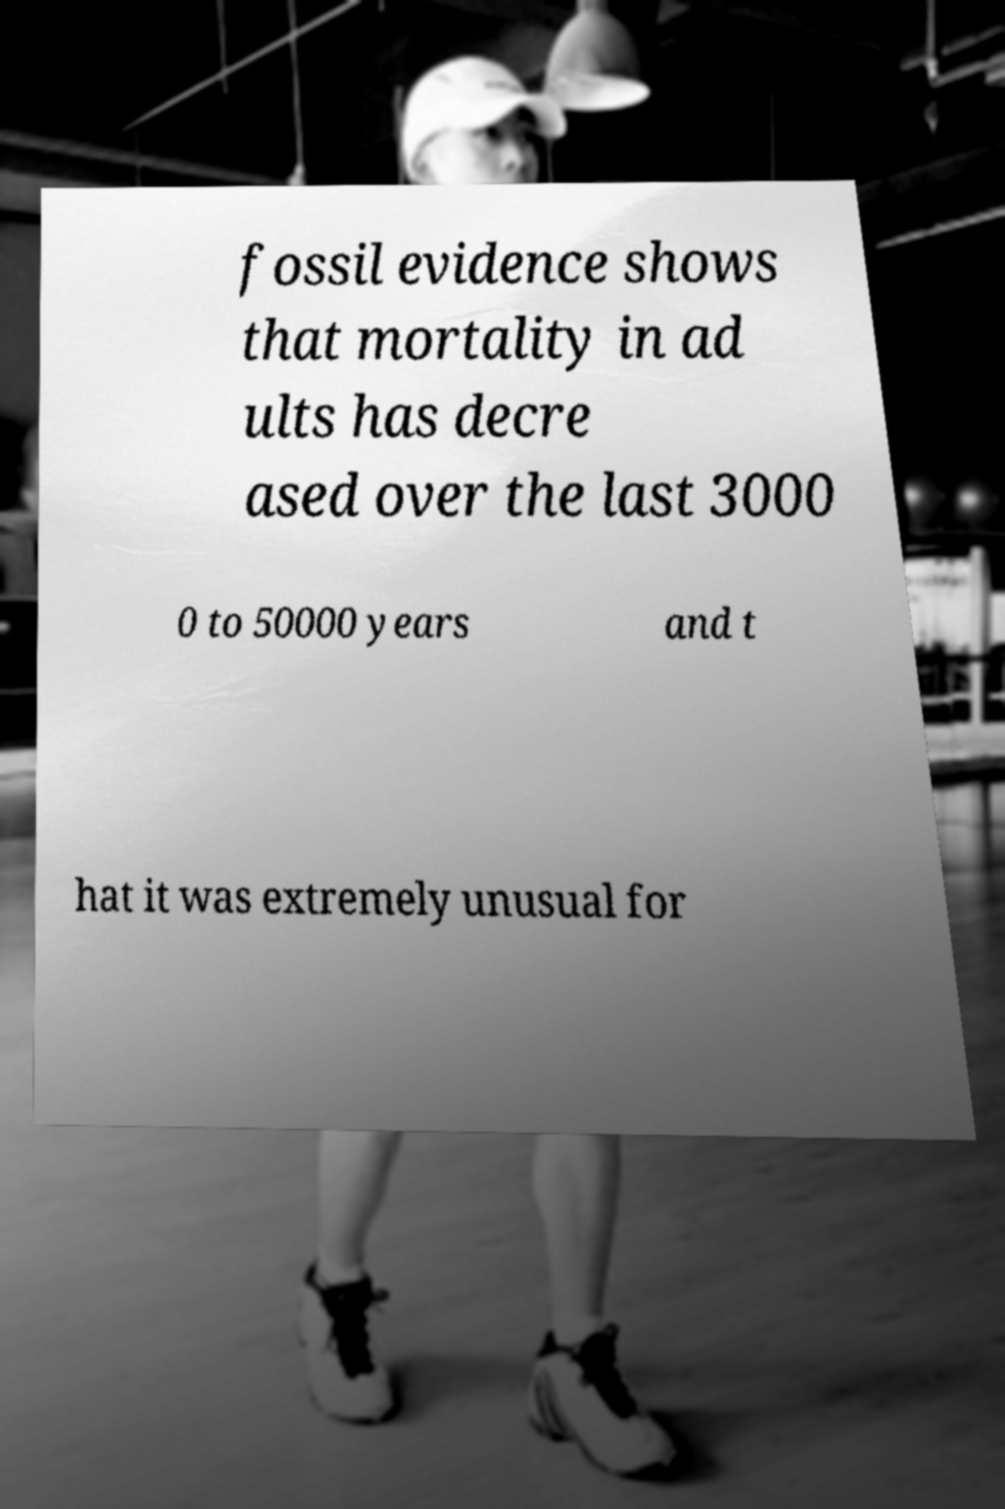I need the written content from this picture converted into text. Can you do that? fossil evidence shows that mortality in ad ults has decre ased over the last 3000 0 to 50000 years and t hat it was extremely unusual for 